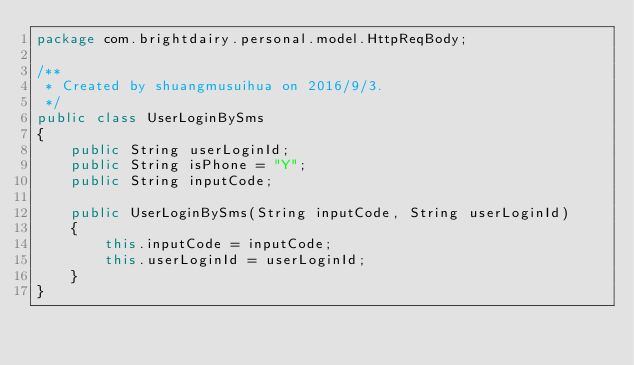<code> <loc_0><loc_0><loc_500><loc_500><_Java_>package com.brightdairy.personal.model.HttpReqBody;

/**
 * Created by shuangmusuihua on 2016/9/3.
 */
public class UserLoginBySms
{
    public String userLoginId;
    public String isPhone = "Y";
    public String inputCode;

    public UserLoginBySms(String inputCode, String userLoginId)
    {
        this.inputCode = inputCode;
        this.userLoginId = userLoginId;
    }
}
</code> 